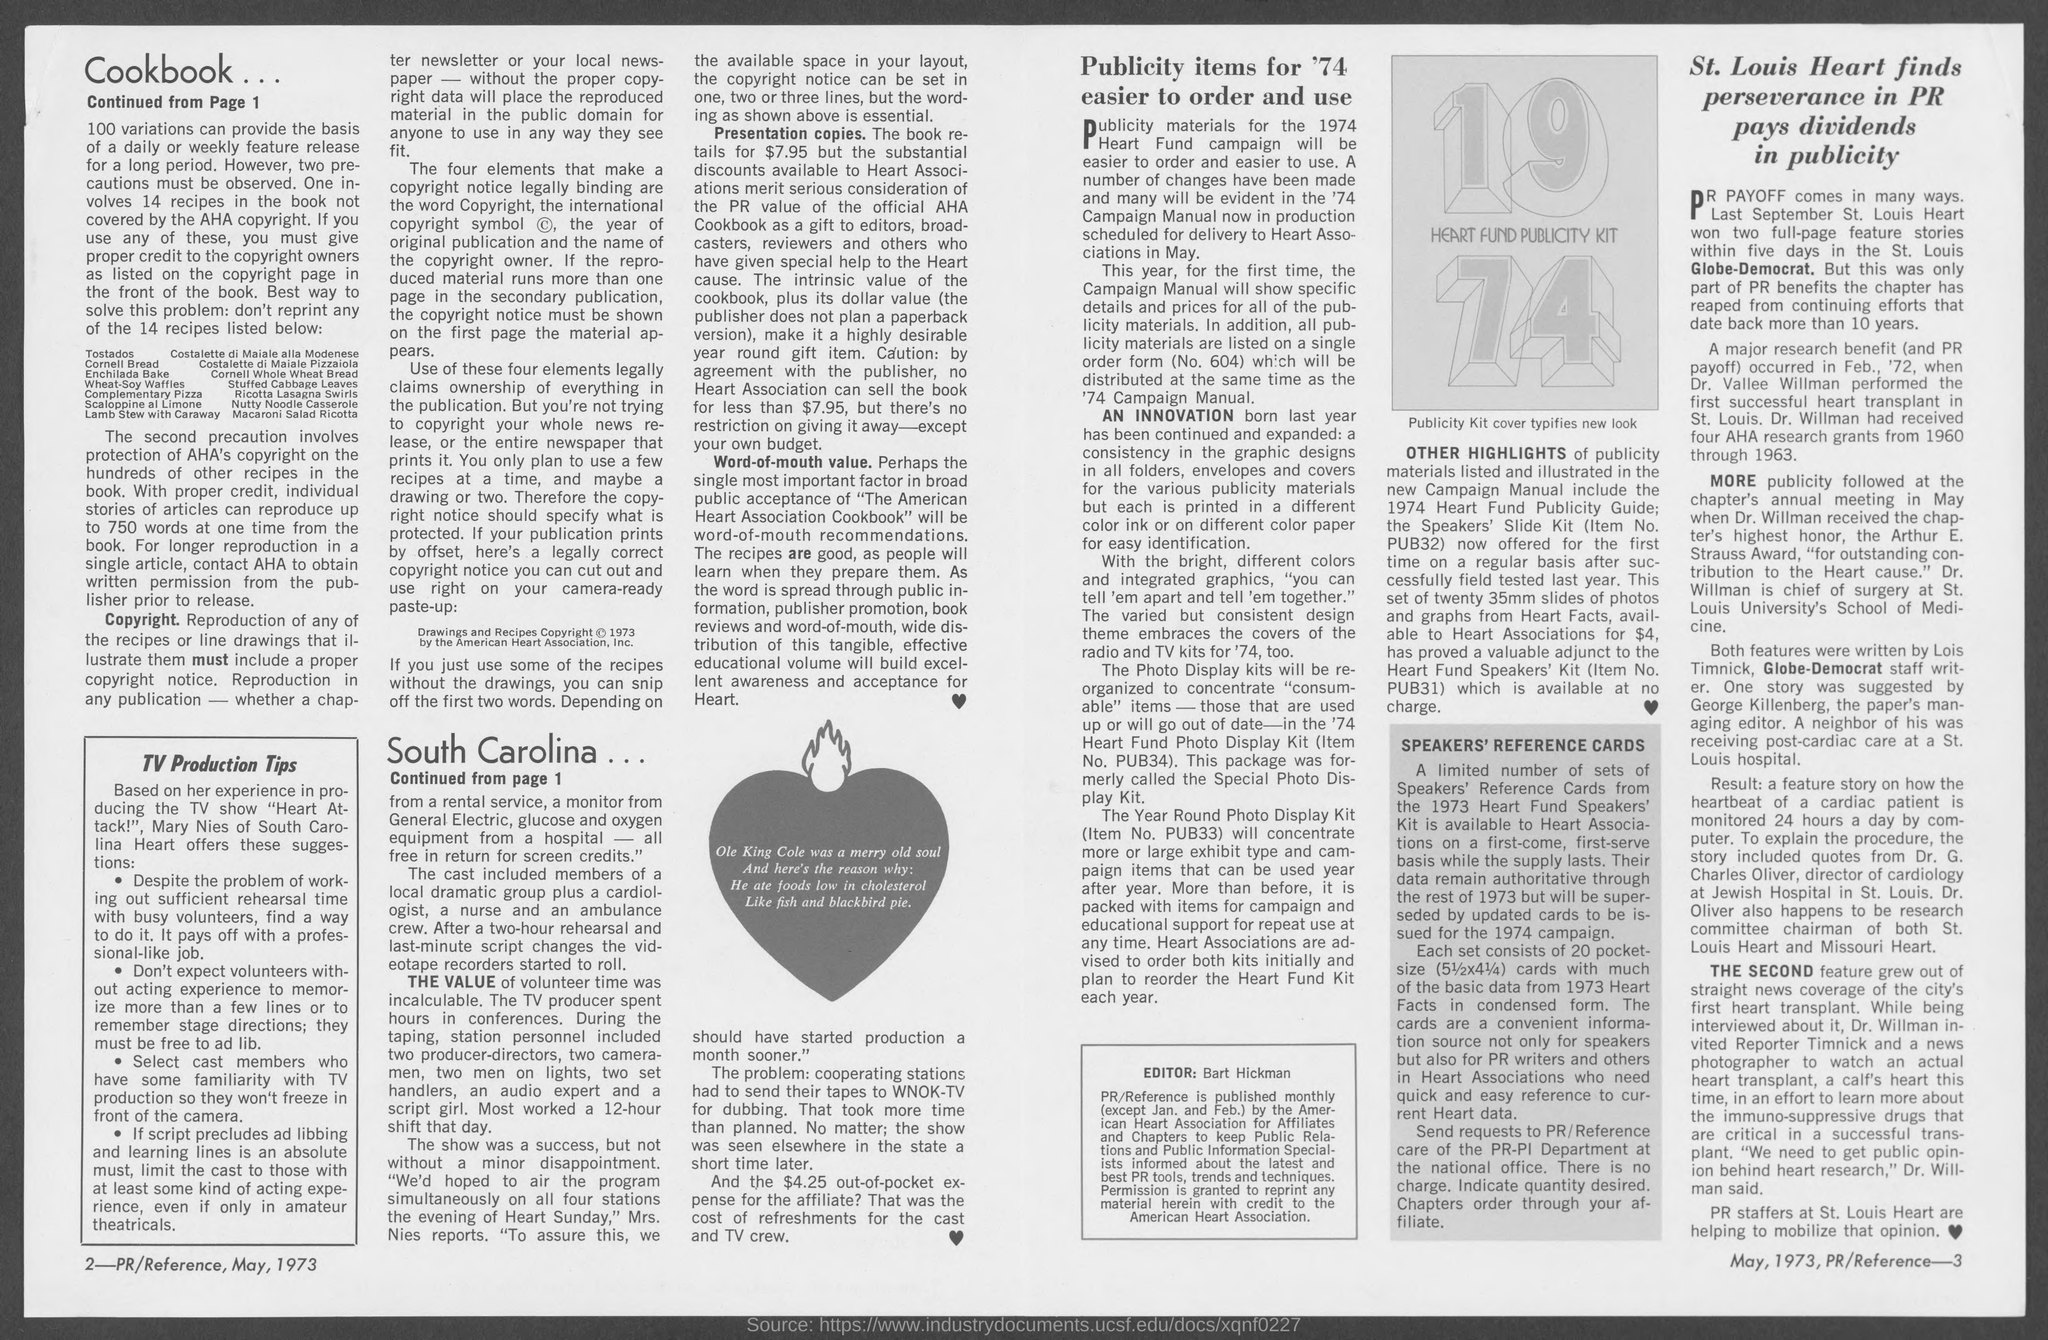Point out several critical features in this image. The book is available for purchase at a retail price of $7.95. The date of publication is May, 1973. 